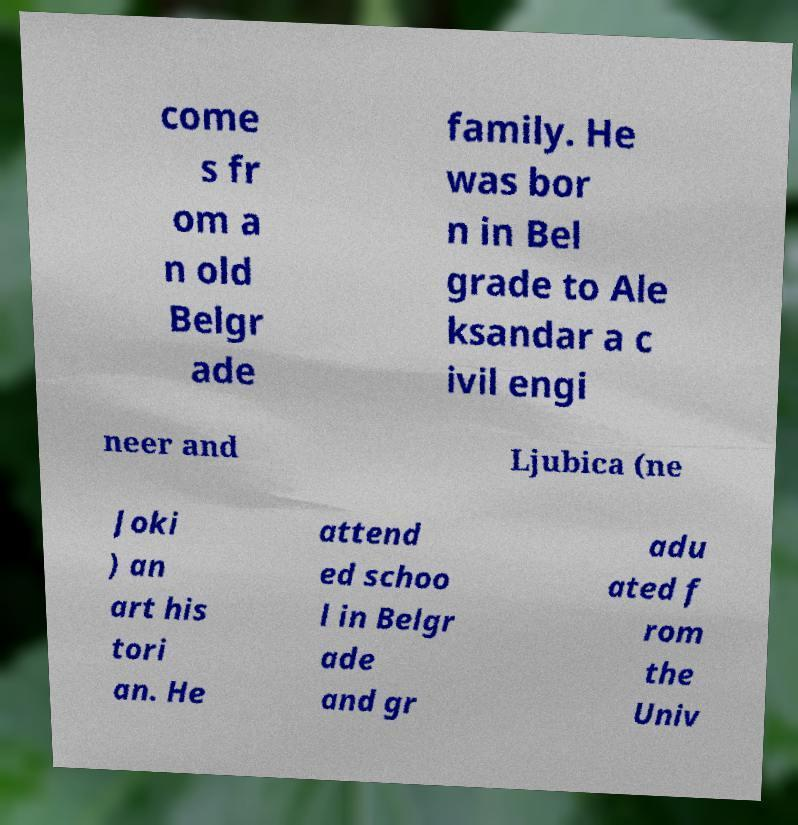Please identify and transcribe the text found in this image. come s fr om a n old Belgr ade family. He was bor n in Bel grade to Ale ksandar a c ivil engi neer and Ljubica (ne Joki ) an art his tori an. He attend ed schoo l in Belgr ade and gr adu ated f rom the Univ 